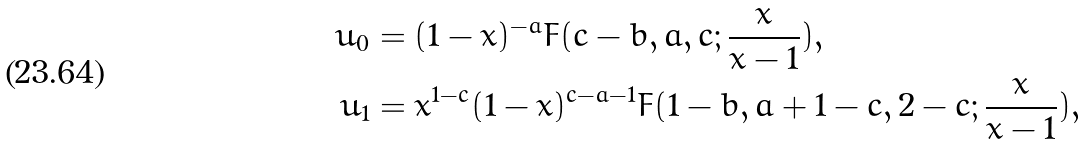<formula> <loc_0><loc_0><loc_500><loc_500>u _ { 0 } & = ( 1 - x ) ^ { - a } F ( c - b , a , c ; \frac { x } { x - 1 } ) , \\ u _ { 1 } & = x ^ { 1 - c } ( 1 - x ) ^ { c - a - 1 } F ( 1 - b , a + 1 - c , 2 - c ; \frac { x } { x - 1 } ) ,</formula> 